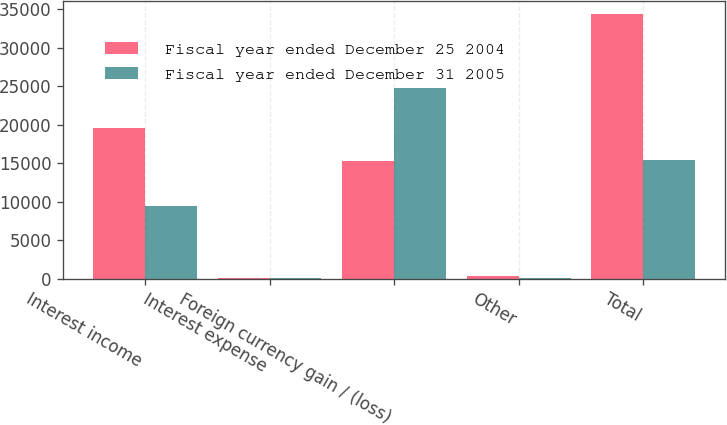<chart> <loc_0><loc_0><loc_500><loc_500><stacked_bar_chart><ecel><fcel>Interest income<fcel>Interest expense<fcel>Foreign currency gain / (loss)<fcel>Other<fcel>Total<nl><fcel>Fiscal year ended December 25 2004<fcel>19586<fcel>48<fcel>15265<fcel>373<fcel>34430<nl><fcel>Fiscal year ended December 31 2005<fcel>9419<fcel>38<fcel>24819<fcel>19<fcel>15457<nl></chart> 